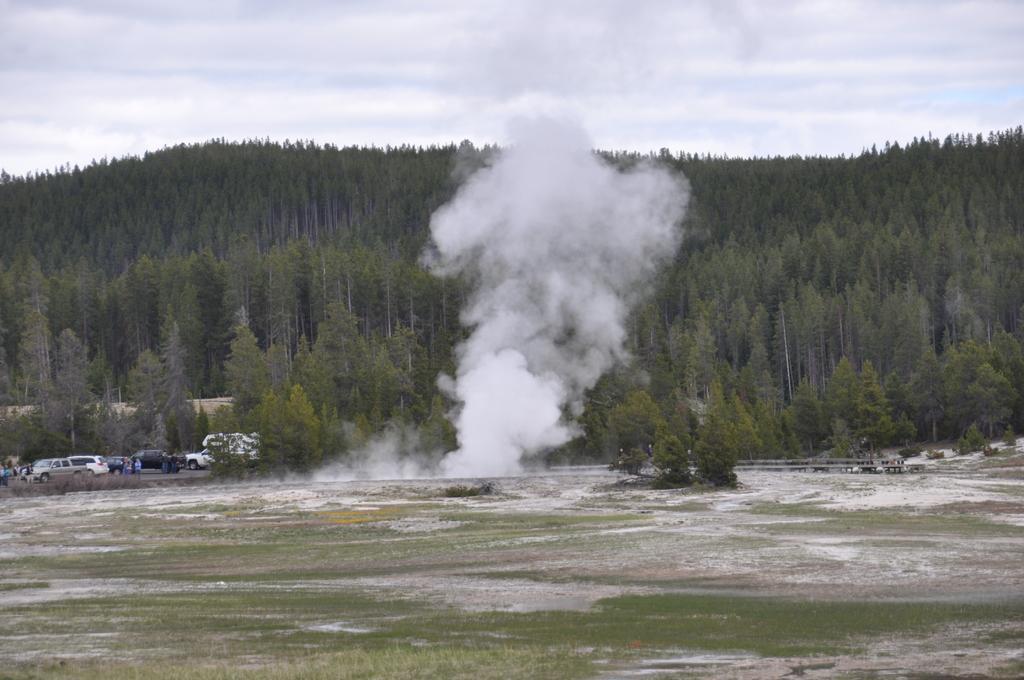How would you summarize this image in a sentence or two? In this picture we can see some grass on the ground. We can see some smoke in the air. There are a few vehicles on the road on the left side. We can see a few trees from left to right. Sky is cloudy. 